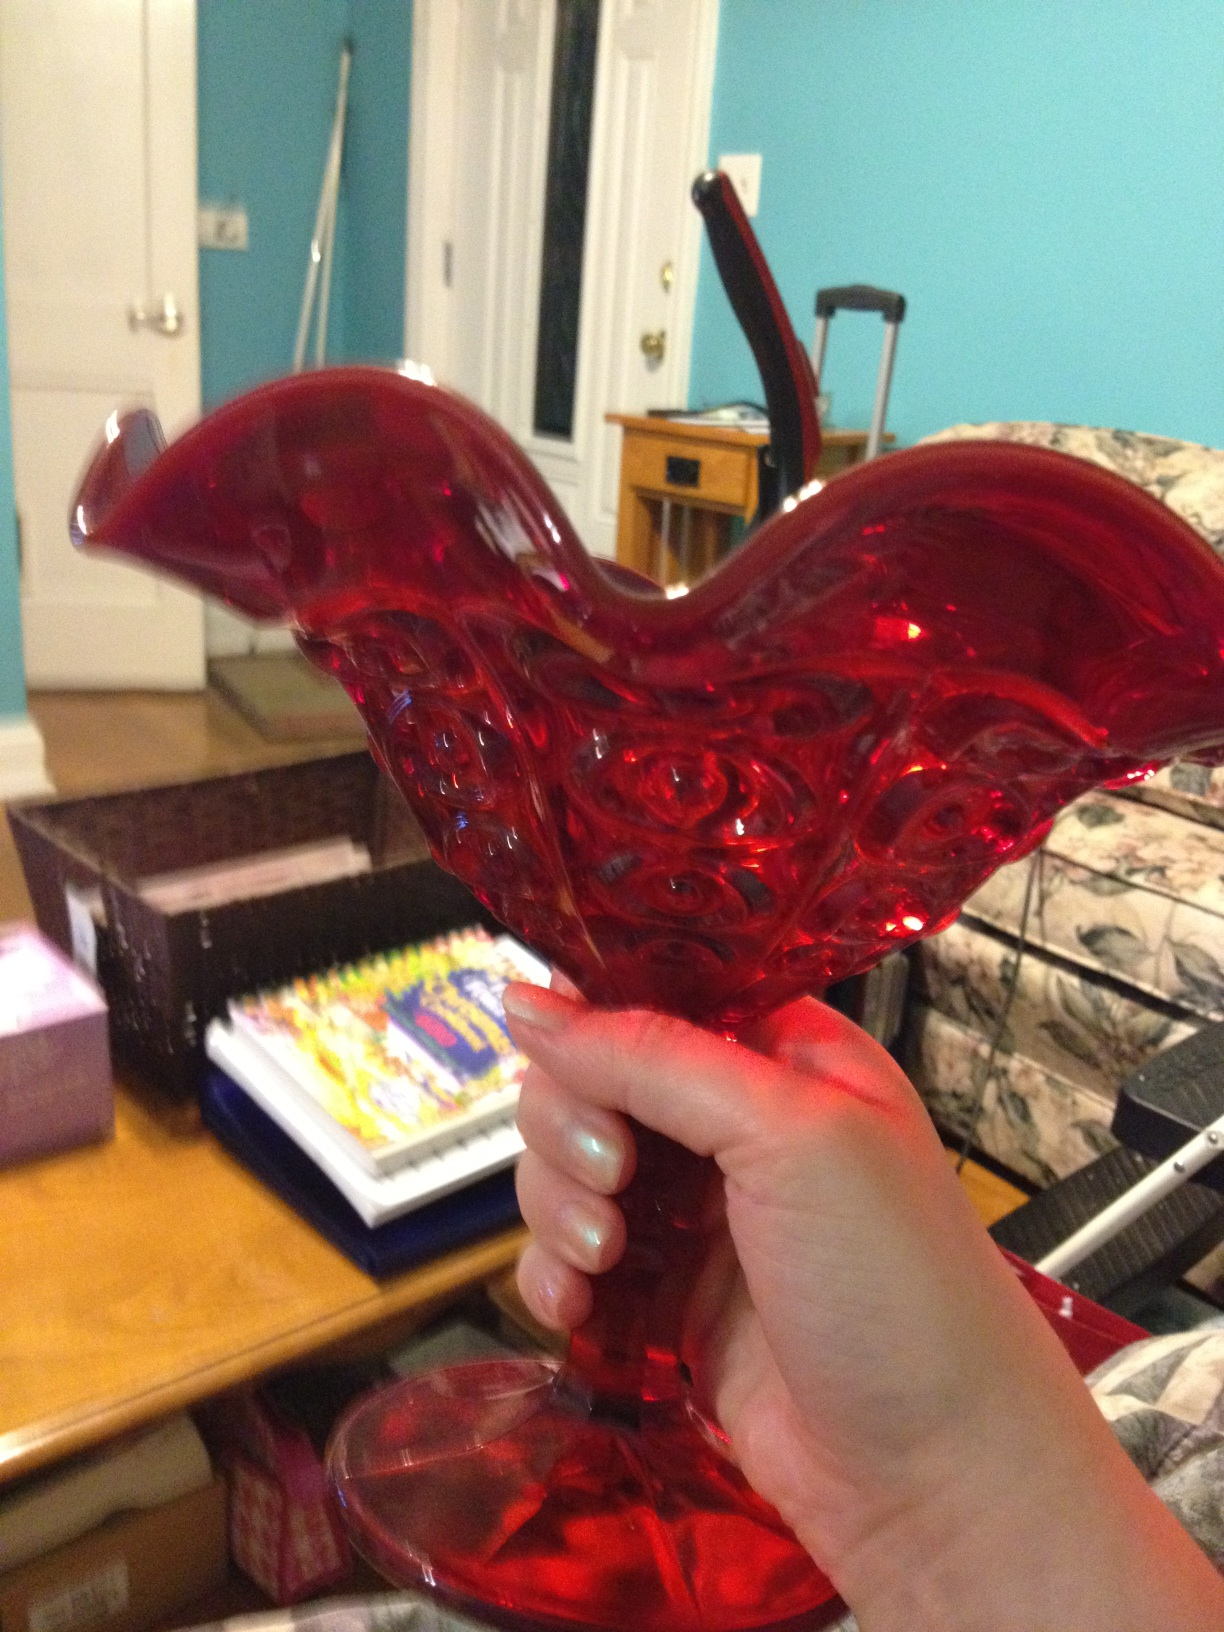What are some potential design and color matching ideas using this vase in home decor? This stunning red vase can be paired with neutral-colored furniture to make it stand out as a focal point in the room. It can complement a white or beige backdrop to create a striking contrast. Alternatively, placing it in a room with deep, rich colors like navy blue or emerald green can enhance its luxurious look. For a cohesive style, adding red accents through cushions, artwork, or other decorative items can tie the room together seamlessly. 